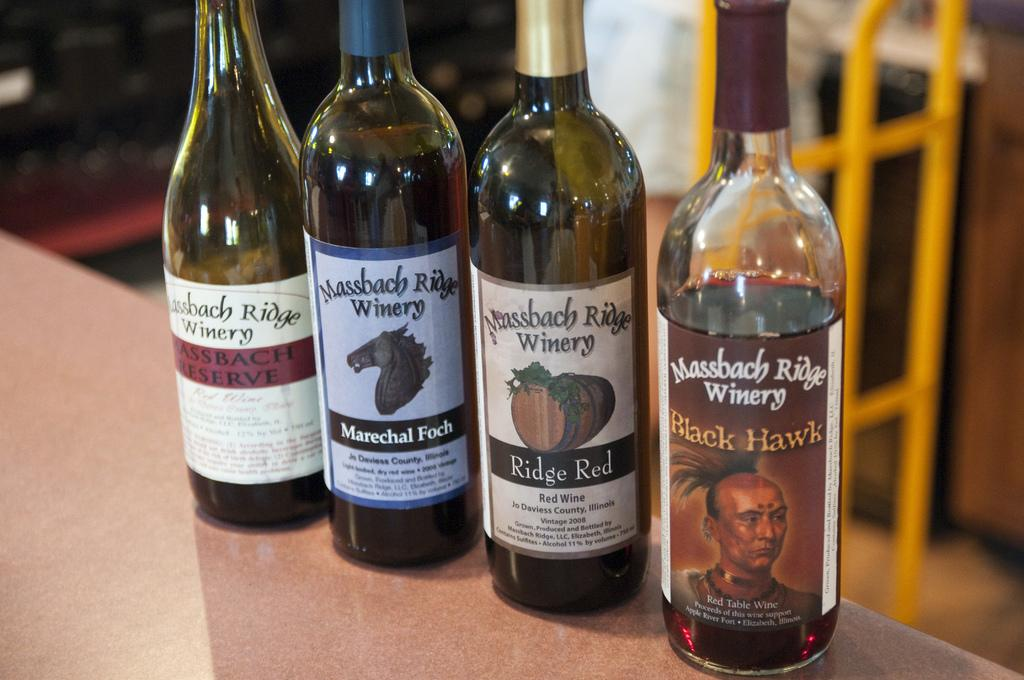<image>
Share a concise interpretation of the image provided. Four bottles of wine from Massbach Ridge Winery. 